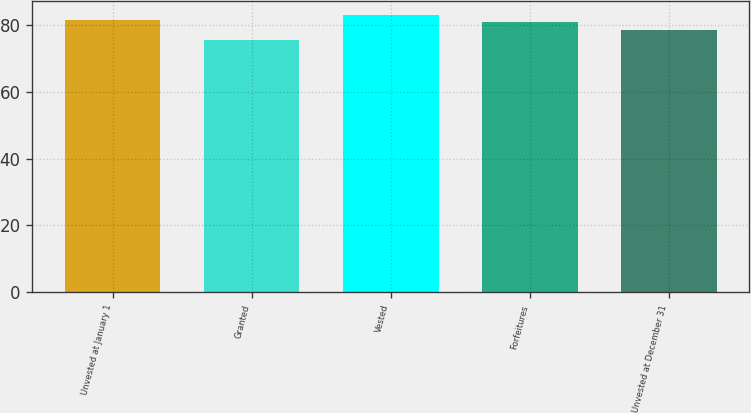Convert chart. <chart><loc_0><loc_0><loc_500><loc_500><bar_chart><fcel>Unvested at January 1<fcel>Granted<fcel>Vested<fcel>Forfeitures<fcel>Unvested at December 31<nl><fcel>81.65<fcel>75.57<fcel>83.18<fcel>80.89<fcel>78.7<nl></chart> 